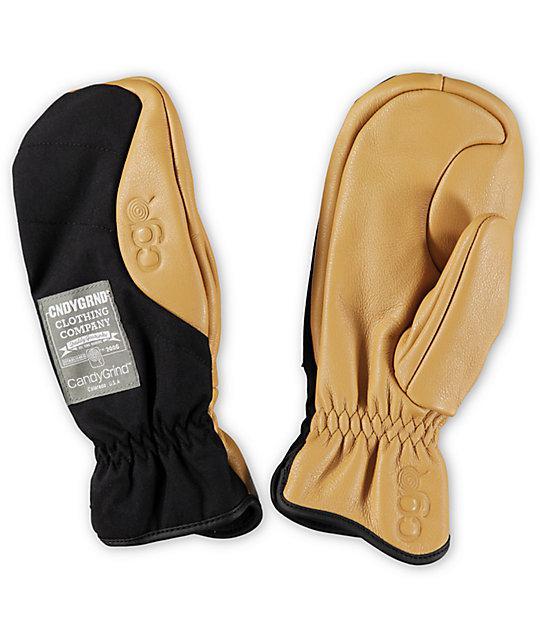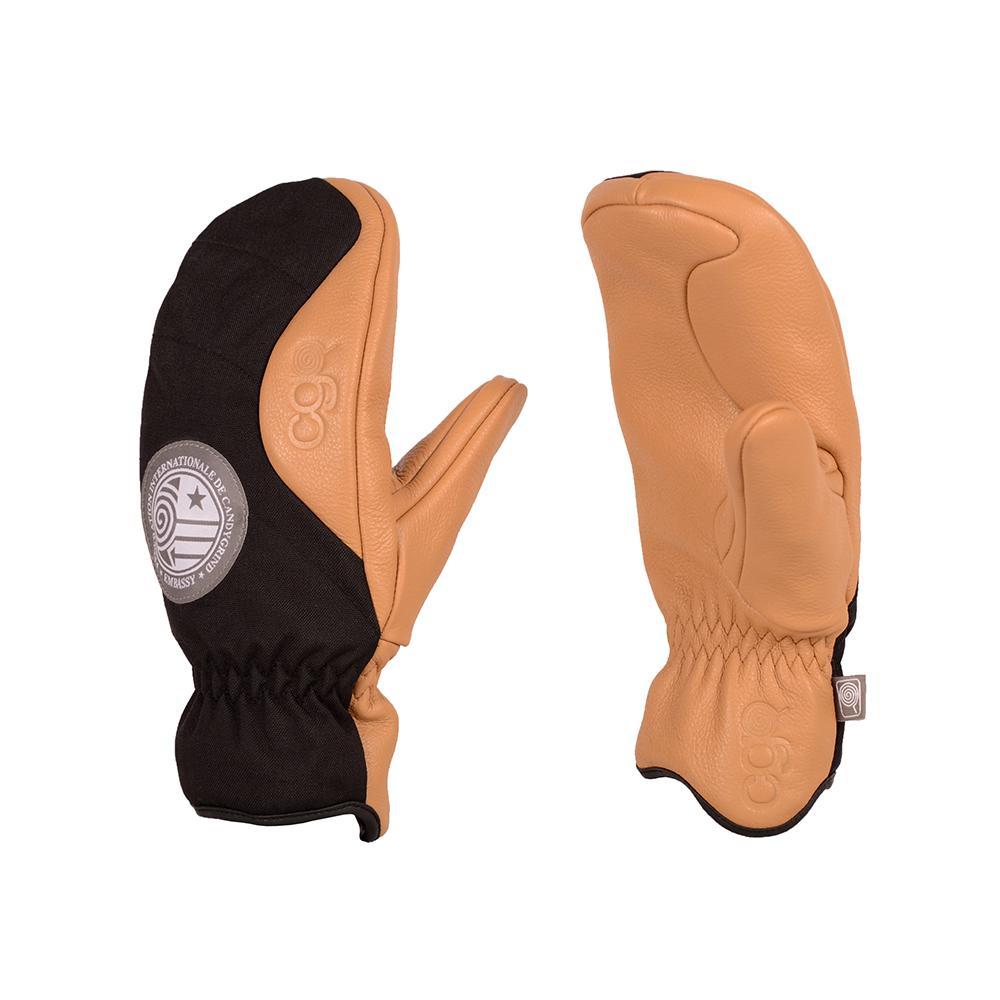The first image is the image on the left, the second image is the image on the right. Given the left and right images, does the statement "Two pairs of mittens are shown in front and back views, but with only one pair is one thumb section extended to the side." hold true? Answer yes or no. Yes. The first image is the image on the left, the second image is the image on the right. Considering the images on both sides, is "Each image shows the front and reverse sides of a pair of mittens, with the cuff opening at the bottom." valid? Answer yes or no. Yes. 